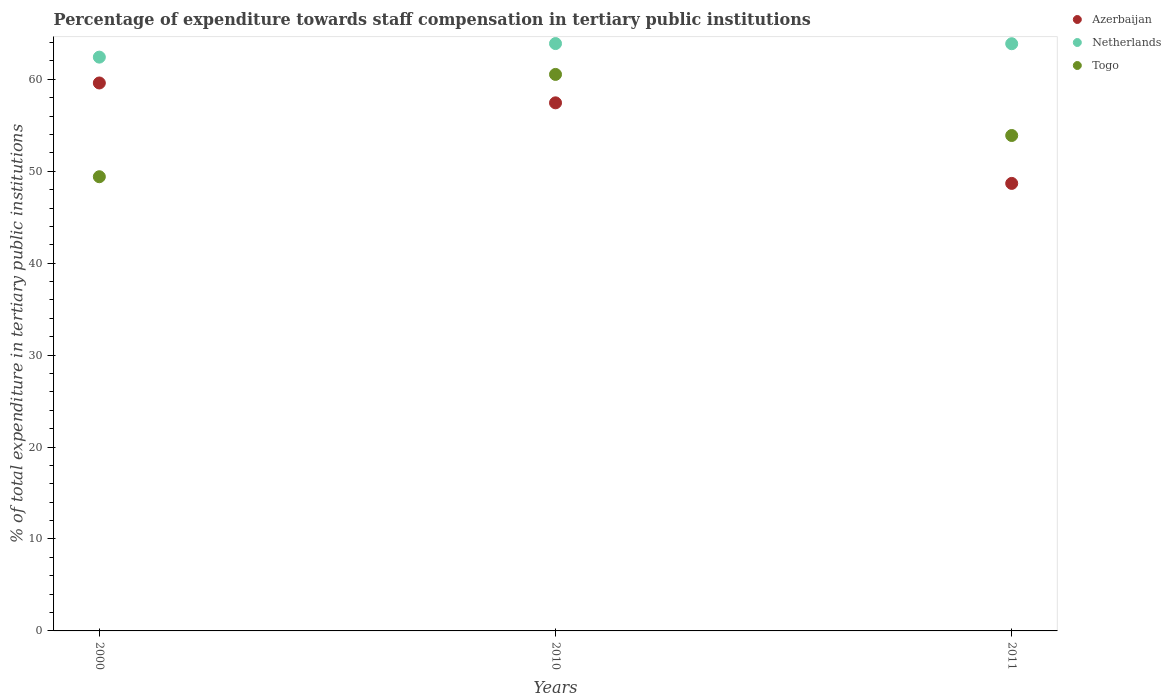How many different coloured dotlines are there?
Give a very brief answer. 3. Is the number of dotlines equal to the number of legend labels?
Keep it short and to the point. Yes. What is the percentage of expenditure towards staff compensation in Azerbaijan in 2011?
Ensure brevity in your answer.  48.68. Across all years, what is the maximum percentage of expenditure towards staff compensation in Netherlands?
Give a very brief answer. 63.89. Across all years, what is the minimum percentage of expenditure towards staff compensation in Netherlands?
Provide a succinct answer. 62.41. What is the total percentage of expenditure towards staff compensation in Netherlands in the graph?
Your answer should be compact. 190.17. What is the difference between the percentage of expenditure towards staff compensation in Azerbaijan in 2000 and that in 2010?
Your response must be concise. 2.16. What is the difference between the percentage of expenditure towards staff compensation in Netherlands in 2011 and the percentage of expenditure towards staff compensation in Azerbaijan in 2010?
Ensure brevity in your answer.  6.43. What is the average percentage of expenditure towards staff compensation in Azerbaijan per year?
Keep it short and to the point. 55.24. In the year 2000, what is the difference between the percentage of expenditure towards staff compensation in Netherlands and percentage of expenditure towards staff compensation in Azerbaijan?
Your answer should be compact. 2.81. In how many years, is the percentage of expenditure towards staff compensation in Togo greater than 46 %?
Make the answer very short. 3. What is the ratio of the percentage of expenditure towards staff compensation in Togo in 2000 to that in 2011?
Give a very brief answer. 0.92. Is the percentage of expenditure towards staff compensation in Azerbaijan in 2000 less than that in 2010?
Provide a succinct answer. No. Is the difference between the percentage of expenditure towards staff compensation in Netherlands in 2000 and 2011 greater than the difference between the percentage of expenditure towards staff compensation in Azerbaijan in 2000 and 2011?
Provide a short and direct response. No. What is the difference between the highest and the second highest percentage of expenditure towards staff compensation in Togo?
Offer a very short reply. 6.64. What is the difference between the highest and the lowest percentage of expenditure towards staff compensation in Togo?
Provide a short and direct response. 11.13. Is the sum of the percentage of expenditure towards staff compensation in Azerbaijan in 2000 and 2010 greater than the maximum percentage of expenditure towards staff compensation in Netherlands across all years?
Give a very brief answer. Yes. Does the percentage of expenditure towards staff compensation in Togo monotonically increase over the years?
Give a very brief answer. No. How many dotlines are there?
Provide a succinct answer. 3. How many years are there in the graph?
Provide a succinct answer. 3. What is the difference between two consecutive major ticks on the Y-axis?
Your answer should be very brief. 10. Are the values on the major ticks of Y-axis written in scientific E-notation?
Your answer should be compact. No. Does the graph contain any zero values?
Provide a short and direct response. No. What is the title of the graph?
Offer a terse response. Percentage of expenditure towards staff compensation in tertiary public institutions. Does "Indonesia" appear as one of the legend labels in the graph?
Your answer should be very brief. No. What is the label or title of the X-axis?
Your response must be concise. Years. What is the label or title of the Y-axis?
Make the answer very short. % of total expenditure in tertiary public institutions. What is the % of total expenditure in tertiary public institutions of Azerbaijan in 2000?
Provide a short and direct response. 59.6. What is the % of total expenditure in tertiary public institutions of Netherlands in 2000?
Ensure brevity in your answer.  62.41. What is the % of total expenditure in tertiary public institutions of Togo in 2000?
Provide a succinct answer. 49.4. What is the % of total expenditure in tertiary public institutions in Azerbaijan in 2010?
Your answer should be very brief. 57.44. What is the % of total expenditure in tertiary public institutions in Netherlands in 2010?
Ensure brevity in your answer.  63.89. What is the % of total expenditure in tertiary public institutions of Togo in 2010?
Offer a terse response. 60.53. What is the % of total expenditure in tertiary public institutions of Azerbaijan in 2011?
Your answer should be compact. 48.68. What is the % of total expenditure in tertiary public institutions in Netherlands in 2011?
Keep it short and to the point. 63.87. What is the % of total expenditure in tertiary public institutions of Togo in 2011?
Make the answer very short. 53.89. Across all years, what is the maximum % of total expenditure in tertiary public institutions in Azerbaijan?
Give a very brief answer. 59.6. Across all years, what is the maximum % of total expenditure in tertiary public institutions in Netherlands?
Give a very brief answer. 63.89. Across all years, what is the maximum % of total expenditure in tertiary public institutions of Togo?
Provide a short and direct response. 60.53. Across all years, what is the minimum % of total expenditure in tertiary public institutions of Azerbaijan?
Offer a very short reply. 48.68. Across all years, what is the minimum % of total expenditure in tertiary public institutions of Netherlands?
Your answer should be compact. 62.41. Across all years, what is the minimum % of total expenditure in tertiary public institutions of Togo?
Ensure brevity in your answer.  49.4. What is the total % of total expenditure in tertiary public institutions in Azerbaijan in the graph?
Your answer should be very brief. 165.72. What is the total % of total expenditure in tertiary public institutions of Netherlands in the graph?
Make the answer very short. 190.17. What is the total % of total expenditure in tertiary public institutions of Togo in the graph?
Keep it short and to the point. 163.83. What is the difference between the % of total expenditure in tertiary public institutions of Azerbaijan in 2000 and that in 2010?
Ensure brevity in your answer.  2.16. What is the difference between the % of total expenditure in tertiary public institutions in Netherlands in 2000 and that in 2010?
Your answer should be very brief. -1.48. What is the difference between the % of total expenditure in tertiary public institutions in Togo in 2000 and that in 2010?
Keep it short and to the point. -11.13. What is the difference between the % of total expenditure in tertiary public institutions of Azerbaijan in 2000 and that in 2011?
Your answer should be compact. 10.92. What is the difference between the % of total expenditure in tertiary public institutions in Netherlands in 2000 and that in 2011?
Give a very brief answer. -1.46. What is the difference between the % of total expenditure in tertiary public institutions in Togo in 2000 and that in 2011?
Make the answer very short. -4.48. What is the difference between the % of total expenditure in tertiary public institutions in Azerbaijan in 2010 and that in 2011?
Ensure brevity in your answer.  8.76. What is the difference between the % of total expenditure in tertiary public institutions in Netherlands in 2010 and that in 2011?
Offer a very short reply. 0.02. What is the difference between the % of total expenditure in tertiary public institutions in Togo in 2010 and that in 2011?
Make the answer very short. 6.64. What is the difference between the % of total expenditure in tertiary public institutions in Azerbaijan in 2000 and the % of total expenditure in tertiary public institutions in Netherlands in 2010?
Your answer should be compact. -4.29. What is the difference between the % of total expenditure in tertiary public institutions in Azerbaijan in 2000 and the % of total expenditure in tertiary public institutions in Togo in 2010?
Your answer should be very brief. -0.93. What is the difference between the % of total expenditure in tertiary public institutions in Netherlands in 2000 and the % of total expenditure in tertiary public institutions in Togo in 2010?
Your answer should be compact. 1.88. What is the difference between the % of total expenditure in tertiary public institutions of Azerbaijan in 2000 and the % of total expenditure in tertiary public institutions of Netherlands in 2011?
Your answer should be very brief. -4.27. What is the difference between the % of total expenditure in tertiary public institutions in Azerbaijan in 2000 and the % of total expenditure in tertiary public institutions in Togo in 2011?
Keep it short and to the point. 5.71. What is the difference between the % of total expenditure in tertiary public institutions in Netherlands in 2000 and the % of total expenditure in tertiary public institutions in Togo in 2011?
Your answer should be compact. 8.52. What is the difference between the % of total expenditure in tertiary public institutions in Azerbaijan in 2010 and the % of total expenditure in tertiary public institutions in Netherlands in 2011?
Keep it short and to the point. -6.43. What is the difference between the % of total expenditure in tertiary public institutions in Azerbaijan in 2010 and the % of total expenditure in tertiary public institutions in Togo in 2011?
Offer a terse response. 3.55. What is the average % of total expenditure in tertiary public institutions in Azerbaijan per year?
Your answer should be compact. 55.24. What is the average % of total expenditure in tertiary public institutions of Netherlands per year?
Your answer should be very brief. 63.39. What is the average % of total expenditure in tertiary public institutions in Togo per year?
Give a very brief answer. 54.61. In the year 2000, what is the difference between the % of total expenditure in tertiary public institutions of Azerbaijan and % of total expenditure in tertiary public institutions of Netherlands?
Offer a terse response. -2.81. In the year 2000, what is the difference between the % of total expenditure in tertiary public institutions of Azerbaijan and % of total expenditure in tertiary public institutions of Togo?
Offer a very short reply. 10.2. In the year 2000, what is the difference between the % of total expenditure in tertiary public institutions of Netherlands and % of total expenditure in tertiary public institutions of Togo?
Make the answer very short. 13.01. In the year 2010, what is the difference between the % of total expenditure in tertiary public institutions of Azerbaijan and % of total expenditure in tertiary public institutions of Netherlands?
Give a very brief answer. -6.45. In the year 2010, what is the difference between the % of total expenditure in tertiary public institutions of Azerbaijan and % of total expenditure in tertiary public institutions of Togo?
Keep it short and to the point. -3.09. In the year 2010, what is the difference between the % of total expenditure in tertiary public institutions of Netherlands and % of total expenditure in tertiary public institutions of Togo?
Your answer should be very brief. 3.36. In the year 2011, what is the difference between the % of total expenditure in tertiary public institutions of Azerbaijan and % of total expenditure in tertiary public institutions of Netherlands?
Provide a succinct answer. -15.19. In the year 2011, what is the difference between the % of total expenditure in tertiary public institutions in Azerbaijan and % of total expenditure in tertiary public institutions in Togo?
Provide a short and direct response. -5.21. In the year 2011, what is the difference between the % of total expenditure in tertiary public institutions of Netherlands and % of total expenditure in tertiary public institutions of Togo?
Provide a short and direct response. 9.98. What is the ratio of the % of total expenditure in tertiary public institutions of Azerbaijan in 2000 to that in 2010?
Keep it short and to the point. 1.04. What is the ratio of the % of total expenditure in tertiary public institutions in Netherlands in 2000 to that in 2010?
Keep it short and to the point. 0.98. What is the ratio of the % of total expenditure in tertiary public institutions of Togo in 2000 to that in 2010?
Keep it short and to the point. 0.82. What is the ratio of the % of total expenditure in tertiary public institutions of Azerbaijan in 2000 to that in 2011?
Your answer should be very brief. 1.22. What is the ratio of the % of total expenditure in tertiary public institutions of Netherlands in 2000 to that in 2011?
Offer a very short reply. 0.98. What is the ratio of the % of total expenditure in tertiary public institutions of Togo in 2000 to that in 2011?
Make the answer very short. 0.92. What is the ratio of the % of total expenditure in tertiary public institutions in Azerbaijan in 2010 to that in 2011?
Make the answer very short. 1.18. What is the ratio of the % of total expenditure in tertiary public institutions in Netherlands in 2010 to that in 2011?
Provide a short and direct response. 1. What is the ratio of the % of total expenditure in tertiary public institutions in Togo in 2010 to that in 2011?
Make the answer very short. 1.12. What is the difference between the highest and the second highest % of total expenditure in tertiary public institutions in Azerbaijan?
Offer a very short reply. 2.16. What is the difference between the highest and the second highest % of total expenditure in tertiary public institutions of Netherlands?
Offer a very short reply. 0.02. What is the difference between the highest and the second highest % of total expenditure in tertiary public institutions in Togo?
Provide a succinct answer. 6.64. What is the difference between the highest and the lowest % of total expenditure in tertiary public institutions in Azerbaijan?
Offer a terse response. 10.92. What is the difference between the highest and the lowest % of total expenditure in tertiary public institutions of Netherlands?
Provide a short and direct response. 1.48. What is the difference between the highest and the lowest % of total expenditure in tertiary public institutions of Togo?
Provide a short and direct response. 11.13. 